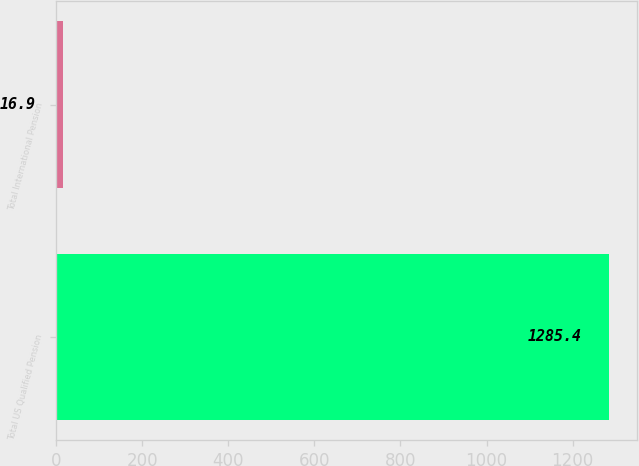<chart> <loc_0><loc_0><loc_500><loc_500><bar_chart><fcel>Total US Qualified Pension<fcel>Total International Pension<nl><fcel>1285.4<fcel>16.9<nl></chart> 